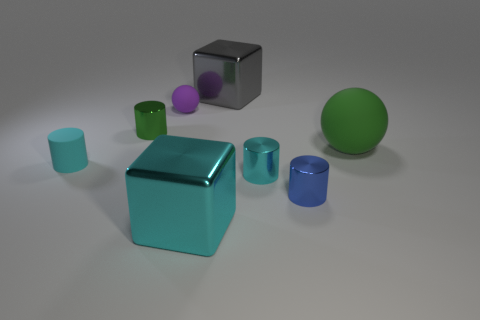Subtract all blue shiny cylinders. How many cylinders are left? 3 Subtract all blue cylinders. How many cylinders are left? 3 Subtract 1 cylinders. How many cylinders are left? 3 Subtract all purple cylinders. Subtract all gray balls. How many cylinders are left? 4 Add 2 blue metallic cylinders. How many objects exist? 10 Subtract all spheres. How many objects are left? 6 Add 8 small red balls. How many small red balls exist? 8 Subtract 0 purple cylinders. How many objects are left? 8 Subtract all tiny blue metal things. Subtract all blue objects. How many objects are left? 6 Add 4 small cyan metal cylinders. How many small cyan metal cylinders are left? 5 